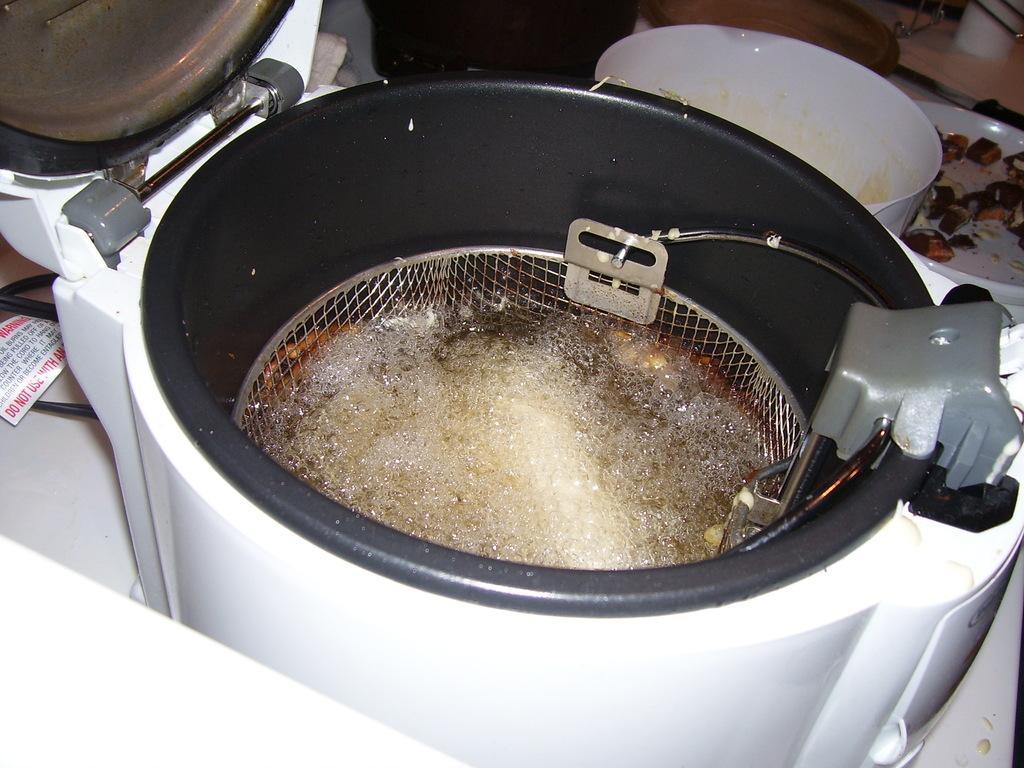Describe this image in one or two sentences. In the picture I can see an air fryer and I can see the bowls on the top right side. 